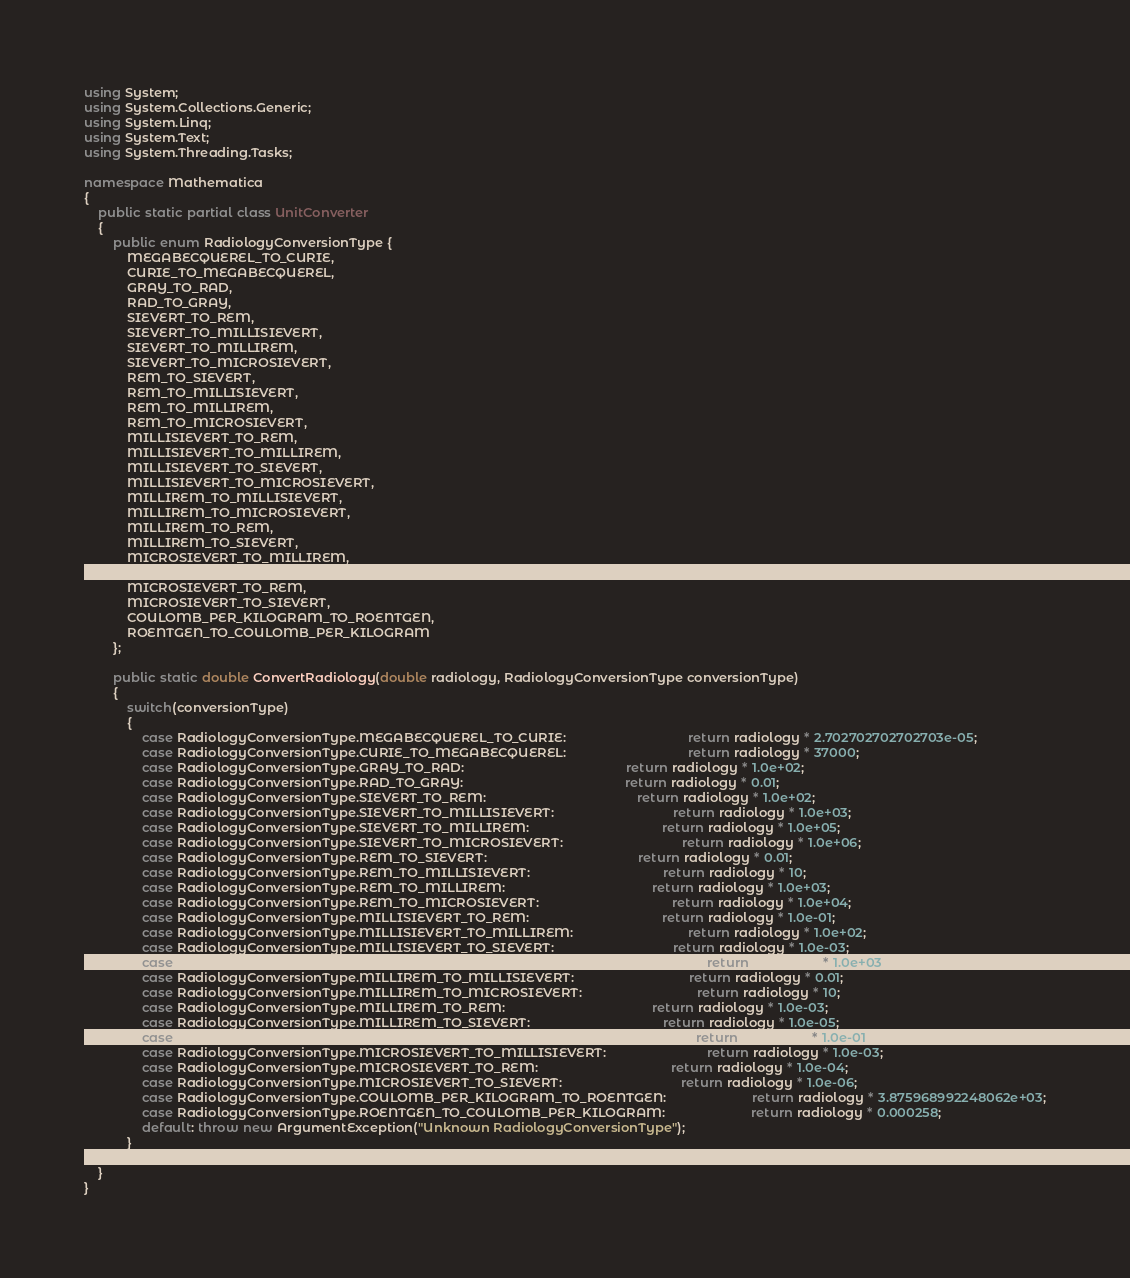Convert code to text. <code><loc_0><loc_0><loc_500><loc_500><_C#_>using System;
using System.Collections.Generic;
using System.Linq;
using System.Text;
using System.Threading.Tasks;

namespace Mathematica
{
    public static partial class UnitConverter
    {
        public enum RadiologyConversionType {
            MEGABECQUEREL_TO_CURIE,
            CURIE_TO_MEGABECQUEREL,
            GRAY_TO_RAD,
            RAD_TO_GRAY,
            SIEVERT_TO_REM,
            SIEVERT_TO_MILLISIEVERT,
            SIEVERT_TO_MILLIREM,
            SIEVERT_TO_MICROSIEVERT,
            REM_TO_SIEVERT,
            REM_TO_MILLISIEVERT,
            REM_TO_MILLIREM,
            REM_TO_MICROSIEVERT,
            MILLISIEVERT_TO_REM,
            MILLISIEVERT_TO_MILLIREM,
            MILLISIEVERT_TO_SIEVERT,
            MILLISIEVERT_TO_MICROSIEVERT,
            MILLIREM_TO_MILLISIEVERT,
            MILLIREM_TO_MICROSIEVERT,
            MILLIREM_TO_REM,
            MILLIREM_TO_SIEVERT,
            MICROSIEVERT_TO_MILLIREM,
            MICROSIEVERT_TO_MILLISIEVERT,
            MICROSIEVERT_TO_REM,
            MICROSIEVERT_TO_SIEVERT,
            COULOMB_PER_KILOGRAM_TO_ROENTGEN,
            ROENTGEN_TO_COULOMB_PER_KILOGRAM
        };
        
        public static double ConvertRadiology(double radiology, RadiologyConversionType conversionType)
        {
            switch(conversionType)
            {
                case RadiologyConversionType.MEGABECQUEREL_TO_CURIE:                                  return radiology * 2.702702702702703e-05;
                case RadiologyConversionType.CURIE_TO_MEGABECQUEREL:                                  return radiology * 37000;
                case RadiologyConversionType.GRAY_TO_RAD:                                             return radiology * 1.0e+02;
                case RadiologyConversionType.RAD_TO_GRAY:                                             return radiology * 0.01;
                case RadiologyConversionType.SIEVERT_TO_REM:                                          return radiology * 1.0e+02;
                case RadiologyConversionType.SIEVERT_TO_MILLISIEVERT:                                 return radiology * 1.0e+03;
                case RadiologyConversionType.SIEVERT_TO_MILLIREM:                                     return radiology * 1.0e+05;
                case RadiologyConversionType.SIEVERT_TO_MICROSIEVERT:                                 return radiology * 1.0e+06;
                case RadiologyConversionType.REM_TO_SIEVERT:                                          return radiology * 0.01;
                case RadiologyConversionType.REM_TO_MILLISIEVERT:                                     return radiology * 10;
                case RadiologyConversionType.REM_TO_MILLIREM:                                         return radiology * 1.0e+03;
                case RadiologyConversionType.REM_TO_MICROSIEVERT:                                     return radiology * 1.0e+04;
                case RadiologyConversionType.MILLISIEVERT_TO_REM:                                     return radiology * 1.0e-01;
                case RadiologyConversionType.MILLISIEVERT_TO_MILLIREM:                                return radiology * 1.0e+02;
                case RadiologyConversionType.MILLISIEVERT_TO_SIEVERT:                                 return radiology * 1.0e-03;
                case RadiologyConversionType.MILLISIEVERT_TO_MICROSIEVERT:                            return radiology * 1.0e+03;
                case RadiologyConversionType.MILLIREM_TO_MILLISIEVERT:                                return radiology * 0.01;
                case RadiologyConversionType.MILLIREM_TO_MICROSIEVERT:                                return radiology * 10;
                case RadiologyConversionType.MILLIREM_TO_REM:                                         return radiology * 1.0e-03;
                case RadiologyConversionType.MILLIREM_TO_SIEVERT:                                     return radiology * 1.0e-05;
                case RadiologyConversionType.MICROSIEVERT_TO_MILLIREM:                                return radiology * 1.0e-01;
                case RadiologyConversionType.MICROSIEVERT_TO_MILLISIEVERT:                            return radiology * 1.0e-03;
                case RadiologyConversionType.MICROSIEVERT_TO_REM:                                     return radiology * 1.0e-04;
                case RadiologyConversionType.MICROSIEVERT_TO_SIEVERT:                                 return radiology * 1.0e-06;
                case RadiologyConversionType.COULOMB_PER_KILOGRAM_TO_ROENTGEN:                        return radiology * 3.875968992248062e+03;
                case RadiologyConversionType.ROENTGEN_TO_COULOMB_PER_KILOGRAM:                        return radiology * 0.000258;
                default: throw new ArgumentException("Unknown RadiologyConversionType");
            }
        }
    }
}

</code> 